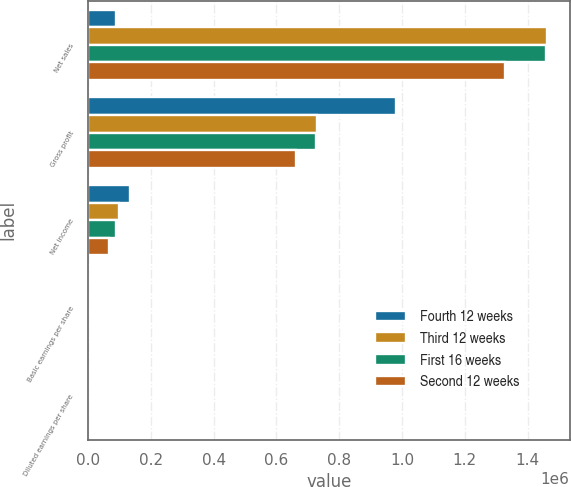Convert chart to OTSL. <chart><loc_0><loc_0><loc_500><loc_500><stacked_bar_chart><ecel><fcel>Net sales<fcel>Gross profit<fcel>Net income<fcel>Basic earnings per share<fcel>Diluted earnings per share<nl><fcel>Fourth 12 weeks<fcel>89503<fcel>980673<fcel>133506<fcel>1.83<fcel>1.79<nl><fcel>Third 12 weeks<fcel>1.46098e+06<fcel>728858<fcel>99606<fcel>1.36<fcel>1.34<nl><fcel>First 16 weeks<fcel>1.45753e+06<fcel>725350<fcel>89503<fcel>1.22<fcel>1.21<nl><fcel>Second 12 weeks<fcel>1.3292e+06<fcel>663155<fcel>65055<fcel>0.89<fcel>0.88<nl></chart> 